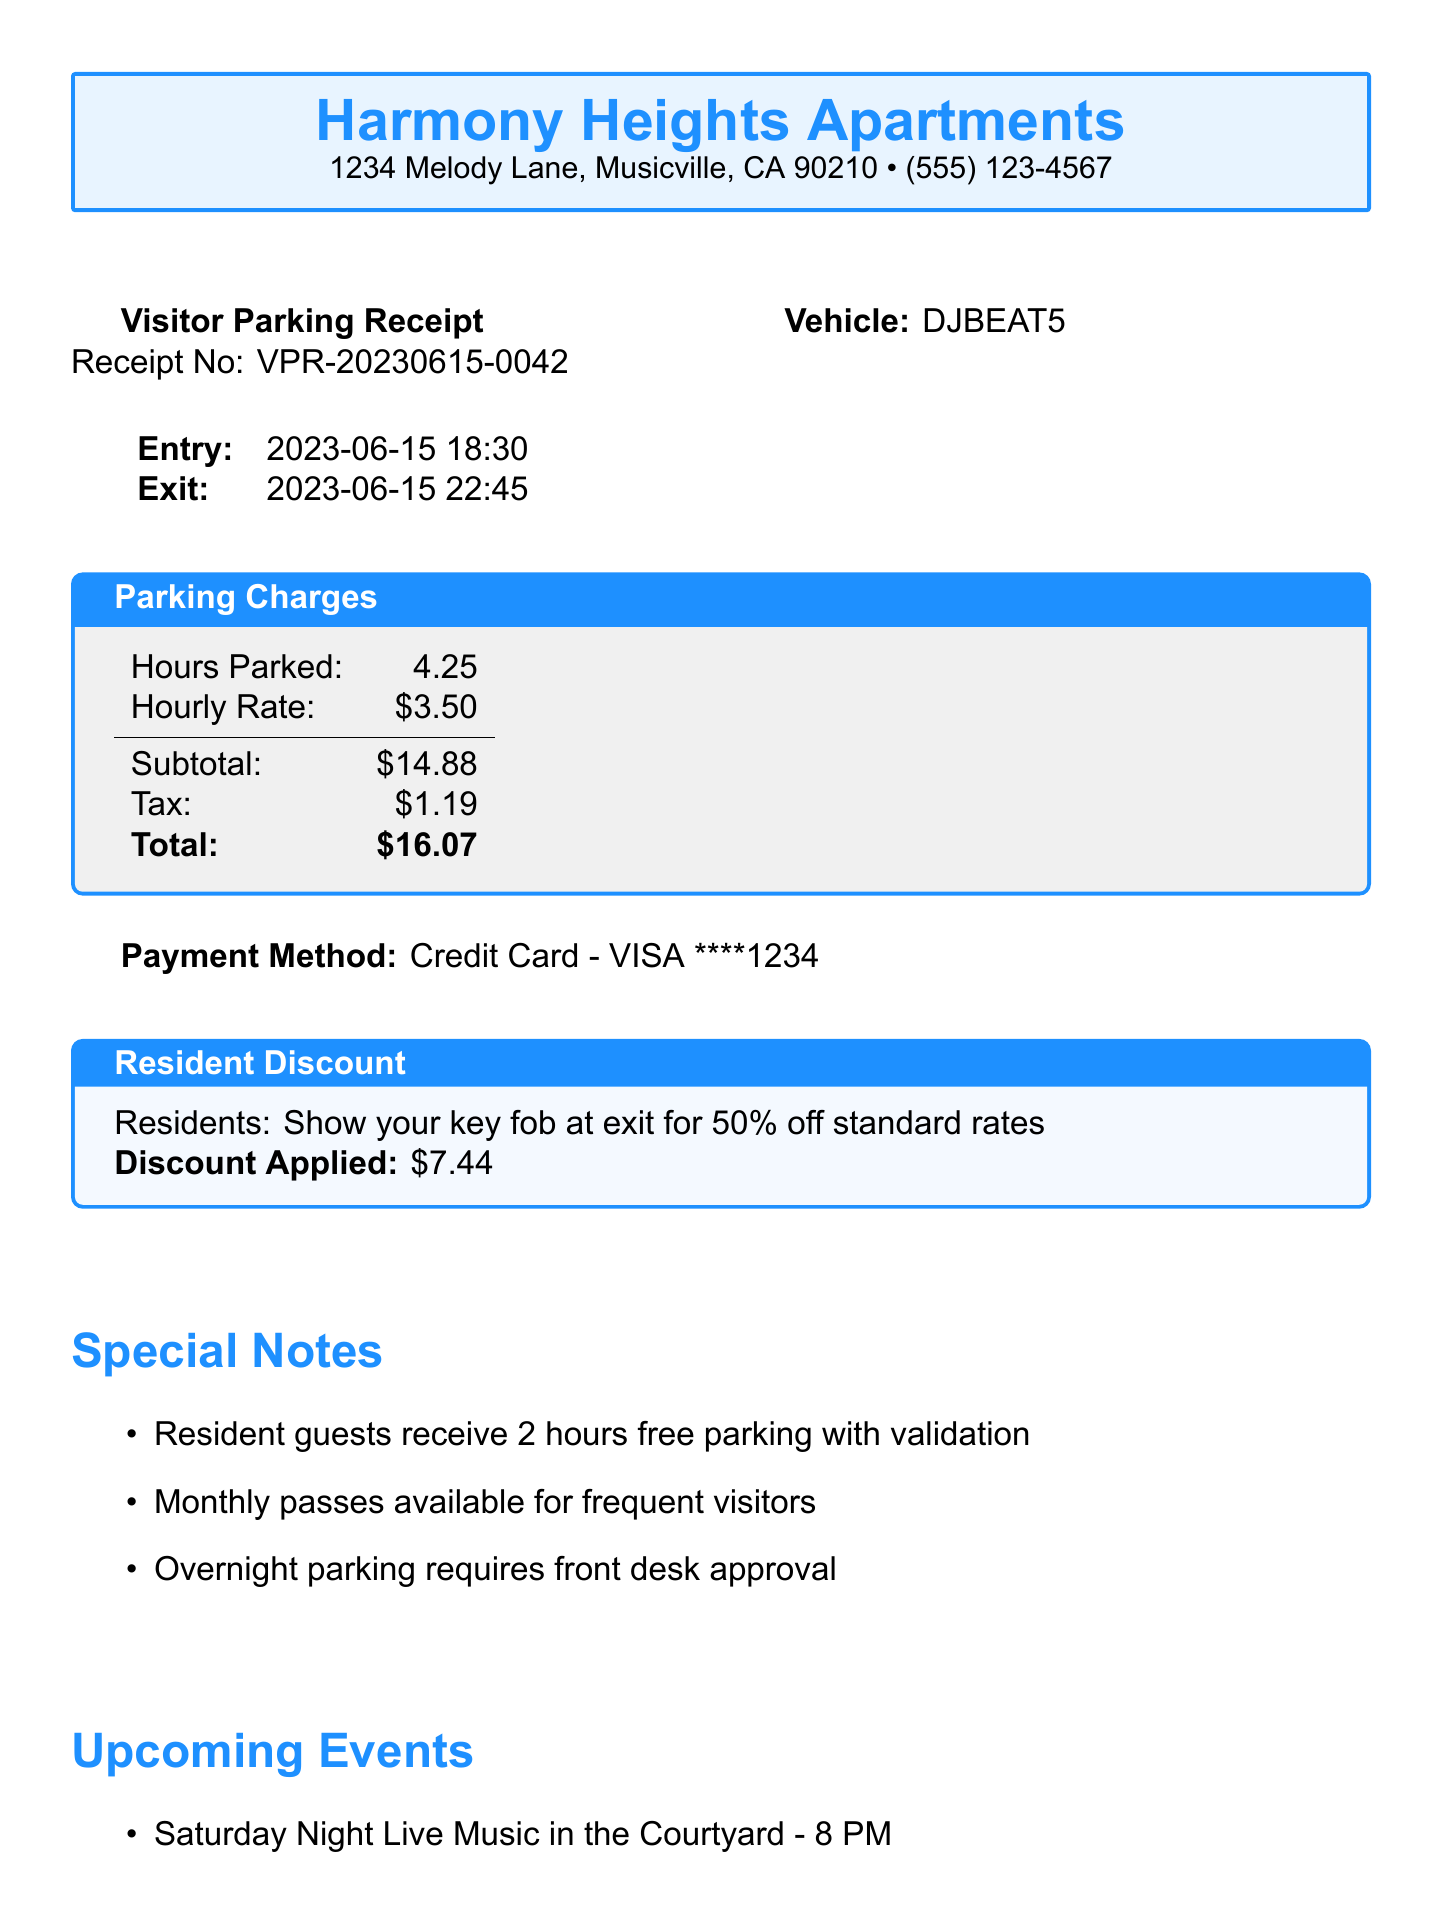What is the total parking fee? The total parking fee is calculated by adding the subtotal and tax, which sums to $14.88 + $1.19 = $16.07.
Answer: $16.07 What is the entry time? The entry time is explicitly stated in the document as the time when the vehicle entered the parking lot.
Answer: 2023-06-15 18:30 What is the vehicle license plate? The license plate is given in the vehicle information section of the document.
Answer: DJBEAT5 How many hours was the vehicle parked? The document specifies the duration of parking in hours, which is categorized under charges.
Answer: 4.25 What is the daily maximum parking fee? The daily maximum fee is listed under the parking rates section of the receipt.
Answer: $25.00 Is the resident discount applied? The document specifically states whether a resident discount has been applied and how it works.
Answer: Yes What is required for resident guests to receive free parking? The document mentions the condition necessary for resident guests to qualify for free parking.
Answer: Validation What is the parking lot's name? The name of the parking lot is clearly indicated in the parking information section.
Answer: Visitor Parking What event happens every Friday night? The upcoming events section outlines the recurring event that takes place on Friday evenings.
Answer: DJ Showcase at The Rooftop Lounge - Every Friday 9 PM-1 AM 